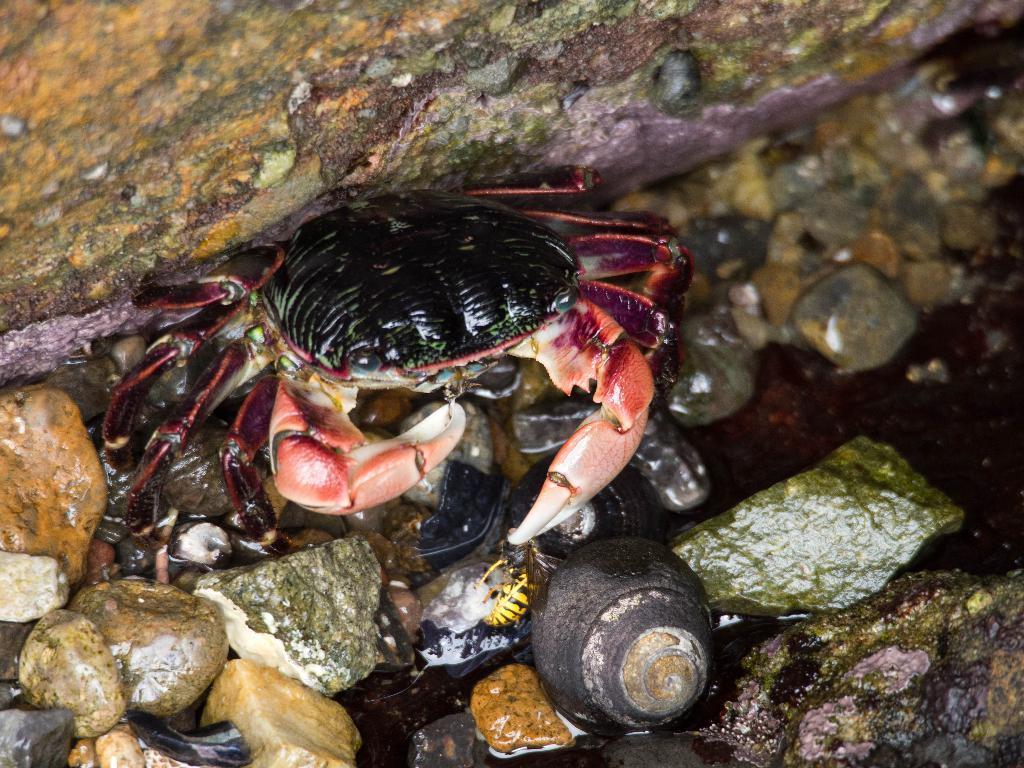In one or two sentences, can you explain what this image depicts? The picture consists of stones, water, snail and a crab. 